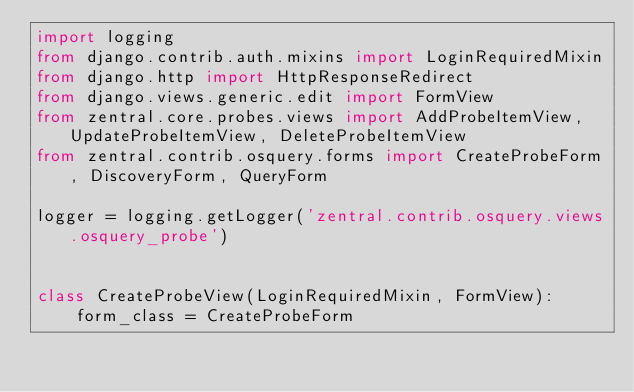Convert code to text. <code><loc_0><loc_0><loc_500><loc_500><_Python_>import logging
from django.contrib.auth.mixins import LoginRequiredMixin
from django.http import HttpResponseRedirect
from django.views.generic.edit import FormView
from zentral.core.probes.views import AddProbeItemView, UpdateProbeItemView, DeleteProbeItemView
from zentral.contrib.osquery.forms import CreateProbeForm, DiscoveryForm, QueryForm

logger = logging.getLogger('zentral.contrib.osquery.views.osquery_probe')


class CreateProbeView(LoginRequiredMixin, FormView):
    form_class = CreateProbeForm</code> 